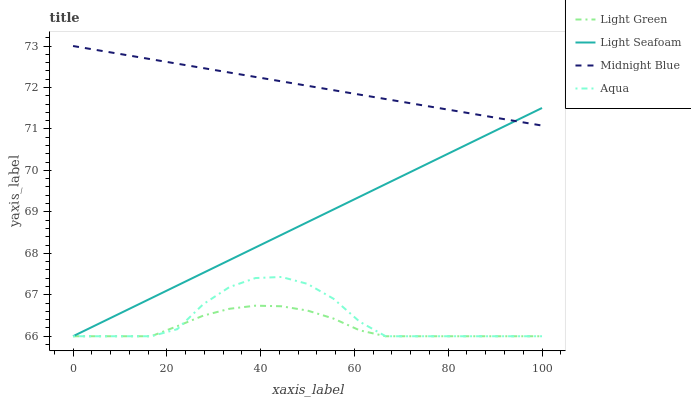Does Light Green have the minimum area under the curve?
Answer yes or no. Yes. Does Midnight Blue have the maximum area under the curve?
Answer yes or no. Yes. Does Aqua have the minimum area under the curve?
Answer yes or no. No. Does Aqua have the maximum area under the curve?
Answer yes or no. No. Is Light Seafoam the smoothest?
Answer yes or no. Yes. Is Aqua the roughest?
Answer yes or no. Yes. Is Midnight Blue the smoothest?
Answer yes or no. No. Is Midnight Blue the roughest?
Answer yes or no. No. Does Light Seafoam have the lowest value?
Answer yes or no. Yes. Does Midnight Blue have the lowest value?
Answer yes or no. No. Does Midnight Blue have the highest value?
Answer yes or no. Yes. Does Aqua have the highest value?
Answer yes or no. No. Is Light Green less than Midnight Blue?
Answer yes or no. Yes. Is Midnight Blue greater than Light Green?
Answer yes or no. Yes. Does Light Green intersect Aqua?
Answer yes or no. Yes. Is Light Green less than Aqua?
Answer yes or no. No. Is Light Green greater than Aqua?
Answer yes or no. No. Does Light Green intersect Midnight Blue?
Answer yes or no. No. 